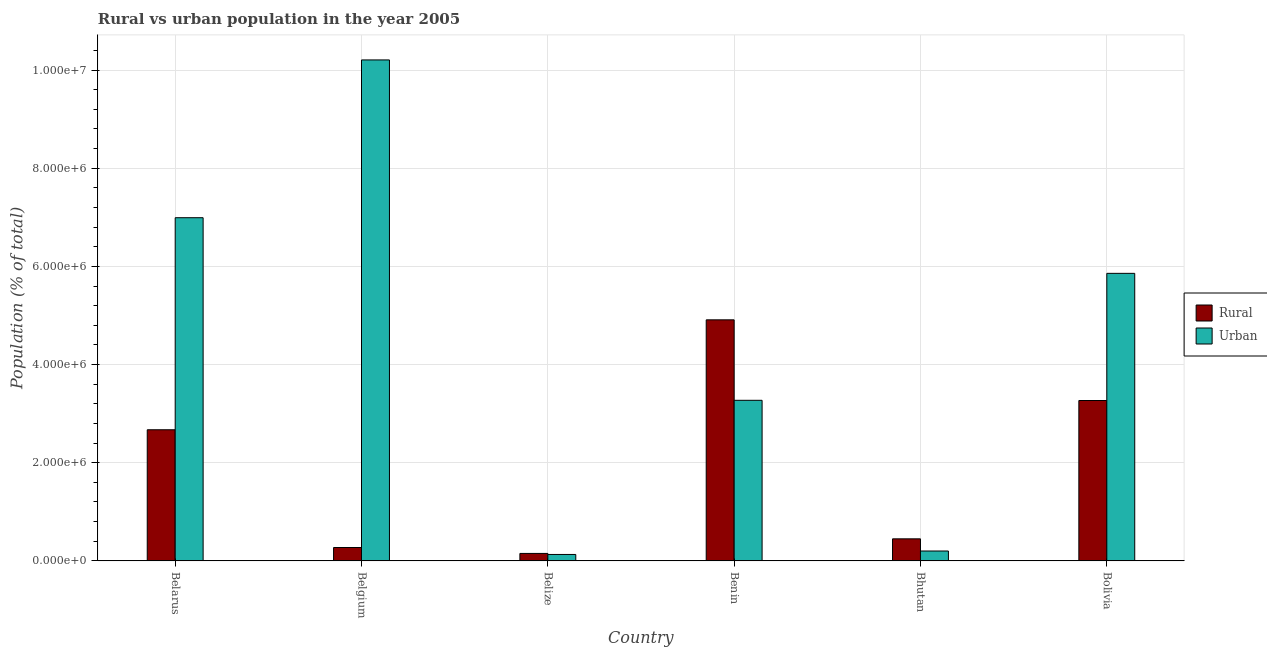How many bars are there on the 6th tick from the left?
Provide a succinct answer. 2. How many bars are there on the 5th tick from the right?
Your answer should be compact. 2. What is the label of the 1st group of bars from the left?
Provide a short and direct response. Belarus. In how many cases, is the number of bars for a given country not equal to the number of legend labels?
Your answer should be compact. 0. What is the rural population density in Belgium?
Keep it short and to the point. 2.73e+05. Across all countries, what is the maximum urban population density?
Your answer should be compact. 1.02e+07. Across all countries, what is the minimum urban population density?
Make the answer very short. 1.31e+05. In which country was the rural population density maximum?
Offer a terse response. Benin. In which country was the rural population density minimum?
Ensure brevity in your answer.  Belize. What is the total urban population density in the graph?
Offer a very short reply. 2.67e+07. What is the difference between the urban population density in Belize and that in Bhutan?
Offer a terse response. -7.04e+04. What is the difference between the rural population density in Benin and the urban population density in Bhutan?
Make the answer very short. 4.71e+06. What is the average urban population density per country?
Offer a very short reply. 4.44e+06. What is the difference between the rural population density and urban population density in Belgium?
Offer a terse response. -9.93e+06. What is the ratio of the urban population density in Belarus to that in Benin?
Make the answer very short. 2.14. What is the difference between the highest and the second highest rural population density?
Make the answer very short. 1.64e+06. What is the difference between the highest and the lowest rural population density?
Your answer should be compact. 4.76e+06. In how many countries, is the urban population density greater than the average urban population density taken over all countries?
Your answer should be very brief. 3. What does the 2nd bar from the left in Bolivia represents?
Provide a succinct answer. Urban. What does the 1st bar from the right in Belgium represents?
Your answer should be compact. Urban. Are all the bars in the graph horizontal?
Ensure brevity in your answer.  No. How many countries are there in the graph?
Provide a succinct answer. 6. What is the difference between two consecutive major ticks on the Y-axis?
Provide a succinct answer. 2.00e+06. Does the graph contain any zero values?
Provide a short and direct response. No. Does the graph contain grids?
Your response must be concise. Yes. How are the legend labels stacked?
Make the answer very short. Vertical. What is the title of the graph?
Make the answer very short. Rural vs urban population in the year 2005. What is the label or title of the Y-axis?
Offer a terse response. Population (% of total). What is the Population (% of total) of Rural in Belarus?
Provide a short and direct response. 2.67e+06. What is the Population (% of total) in Urban in Belarus?
Provide a short and direct response. 6.99e+06. What is the Population (% of total) of Rural in Belgium?
Your response must be concise. 2.73e+05. What is the Population (% of total) in Urban in Belgium?
Offer a terse response. 1.02e+07. What is the Population (% of total) of Rural in Belize?
Offer a terse response. 1.52e+05. What is the Population (% of total) in Urban in Belize?
Provide a short and direct response. 1.31e+05. What is the Population (% of total) of Rural in Benin?
Your answer should be compact. 4.91e+06. What is the Population (% of total) of Urban in Benin?
Ensure brevity in your answer.  3.27e+06. What is the Population (% of total) in Rural in Bhutan?
Your answer should be very brief. 4.50e+05. What is the Population (% of total) of Urban in Bhutan?
Provide a succinct answer. 2.02e+05. What is the Population (% of total) of Rural in Bolivia?
Ensure brevity in your answer.  3.27e+06. What is the Population (% of total) of Urban in Bolivia?
Make the answer very short. 5.86e+06. Across all countries, what is the maximum Population (% of total) of Rural?
Provide a short and direct response. 4.91e+06. Across all countries, what is the maximum Population (% of total) of Urban?
Give a very brief answer. 1.02e+07. Across all countries, what is the minimum Population (% of total) of Rural?
Ensure brevity in your answer.  1.52e+05. Across all countries, what is the minimum Population (% of total) of Urban?
Give a very brief answer. 1.31e+05. What is the total Population (% of total) in Rural in the graph?
Make the answer very short. 1.17e+07. What is the total Population (% of total) of Urban in the graph?
Offer a terse response. 2.67e+07. What is the difference between the Population (% of total) in Rural in Belarus and that in Belgium?
Offer a terse response. 2.40e+06. What is the difference between the Population (% of total) of Urban in Belarus and that in Belgium?
Ensure brevity in your answer.  -3.21e+06. What is the difference between the Population (% of total) of Rural in Belarus and that in Belize?
Your answer should be very brief. 2.52e+06. What is the difference between the Population (% of total) of Urban in Belarus and that in Belize?
Your response must be concise. 6.86e+06. What is the difference between the Population (% of total) in Rural in Belarus and that in Benin?
Your answer should be very brief. -2.24e+06. What is the difference between the Population (% of total) of Urban in Belarus and that in Benin?
Provide a succinct answer. 3.72e+06. What is the difference between the Population (% of total) in Rural in Belarus and that in Bhutan?
Keep it short and to the point. 2.22e+06. What is the difference between the Population (% of total) of Urban in Belarus and that in Bhutan?
Your answer should be compact. 6.79e+06. What is the difference between the Population (% of total) in Rural in Belarus and that in Bolivia?
Provide a short and direct response. -5.96e+05. What is the difference between the Population (% of total) of Urban in Belarus and that in Bolivia?
Keep it short and to the point. 1.13e+06. What is the difference between the Population (% of total) in Rural in Belgium and that in Belize?
Provide a short and direct response. 1.21e+05. What is the difference between the Population (% of total) of Urban in Belgium and that in Belize?
Ensure brevity in your answer.  1.01e+07. What is the difference between the Population (% of total) of Rural in Belgium and that in Benin?
Provide a succinct answer. -4.64e+06. What is the difference between the Population (% of total) of Urban in Belgium and that in Benin?
Keep it short and to the point. 6.93e+06. What is the difference between the Population (% of total) in Rural in Belgium and that in Bhutan?
Keep it short and to the point. -1.77e+05. What is the difference between the Population (% of total) of Urban in Belgium and that in Bhutan?
Your answer should be compact. 1.00e+07. What is the difference between the Population (% of total) of Rural in Belgium and that in Bolivia?
Provide a short and direct response. -2.99e+06. What is the difference between the Population (% of total) of Urban in Belgium and that in Bolivia?
Make the answer very short. 4.35e+06. What is the difference between the Population (% of total) in Rural in Belize and that in Benin?
Offer a terse response. -4.76e+06. What is the difference between the Population (% of total) in Urban in Belize and that in Benin?
Offer a terse response. -3.14e+06. What is the difference between the Population (% of total) of Rural in Belize and that in Bhutan?
Offer a terse response. -2.97e+05. What is the difference between the Population (% of total) in Urban in Belize and that in Bhutan?
Offer a terse response. -7.04e+04. What is the difference between the Population (% of total) in Rural in Belize and that in Bolivia?
Your response must be concise. -3.12e+06. What is the difference between the Population (% of total) of Urban in Belize and that in Bolivia?
Offer a terse response. -5.73e+06. What is the difference between the Population (% of total) in Rural in Benin and that in Bhutan?
Provide a succinct answer. 4.46e+06. What is the difference between the Population (% of total) in Urban in Benin and that in Bhutan?
Your answer should be very brief. 3.07e+06. What is the difference between the Population (% of total) in Rural in Benin and that in Bolivia?
Ensure brevity in your answer.  1.64e+06. What is the difference between the Population (% of total) in Urban in Benin and that in Bolivia?
Your response must be concise. -2.59e+06. What is the difference between the Population (% of total) in Rural in Bhutan and that in Bolivia?
Your answer should be very brief. -2.82e+06. What is the difference between the Population (% of total) in Urban in Bhutan and that in Bolivia?
Provide a short and direct response. -5.66e+06. What is the difference between the Population (% of total) of Rural in Belarus and the Population (% of total) of Urban in Belgium?
Make the answer very short. -7.53e+06. What is the difference between the Population (% of total) of Rural in Belarus and the Population (% of total) of Urban in Belize?
Give a very brief answer. 2.54e+06. What is the difference between the Population (% of total) in Rural in Belarus and the Population (% of total) in Urban in Benin?
Offer a terse response. -6.00e+05. What is the difference between the Population (% of total) of Rural in Belarus and the Population (% of total) of Urban in Bhutan?
Offer a terse response. 2.47e+06. What is the difference between the Population (% of total) of Rural in Belarus and the Population (% of total) of Urban in Bolivia?
Offer a very short reply. -3.19e+06. What is the difference between the Population (% of total) of Rural in Belgium and the Population (% of total) of Urban in Belize?
Provide a succinct answer. 1.42e+05. What is the difference between the Population (% of total) of Rural in Belgium and the Population (% of total) of Urban in Benin?
Your answer should be compact. -3.00e+06. What is the difference between the Population (% of total) of Rural in Belgium and the Population (% of total) of Urban in Bhutan?
Provide a short and direct response. 7.11e+04. What is the difference between the Population (% of total) in Rural in Belgium and the Population (% of total) in Urban in Bolivia?
Make the answer very short. -5.59e+06. What is the difference between the Population (% of total) in Rural in Belize and the Population (% of total) in Urban in Benin?
Offer a terse response. -3.12e+06. What is the difference between the Population (% of total) in Rural in Belize and the Population (% of total) in Urban in Bhutan?
Give a very brief answer. -4.95e+04. What is the difference between the Population (% of total) of Rural in Belize and the Population (% of total) of Urban in Bolivia?
Make the answer very short. -5.71e+06. What is the difference between the Population (% of total) of Rural in Benin and the Population (% of total) of Urban in Bhutan?
Your answer should be very brief. 4.71e+06. What is the difference between the Population (% of total) of Rural in Benin and the Population (% of total) of Urban in Bolivia?
Give a very brief answer. -9.47e+05. What is the difference between the Population (% of total) of Rural in Bhutan and the Population (% of total) of Urban in Bolivia?
Offer a very short reply. -5.41e+06. What is the average Population (% of total) of Rural per country?
Give a very brief answer. 1.95e+06. What is the average Population (% of total) in Urban per country?
Make the answer very short. 4.44e+06. What is the difference between the Population (% of total) of Rural and Population (% of total) of Urban in Belarus?
Keep it short and to the point. -4.32e+06. What is the difference between the Population (% of total) of Rural and Population (% of total) of Urban in Belgium?
Your answer should be very brief. -9.93e+06. What is the difference between the Population (% of total) of Rural and Population (% of total) of Urban in Belize?
Your answer should be very brief. 2.09e+04. What is the difference between the Population (% of total) in Rural and Population (% of total) in Urban in Benin?
Offer a very short reply. 1.64e+06. What is the difference between the Population (% of total) of Rural and Population (% of total) of Urban in Bhutan?
Provide a succinct answer. 2.48e+05. What is the difference between the Population (% of total) of Rural and Population (% of total) of Urban in Bolivia?
Offer a terse response. -2.59e+06. What is the ratio of the Population (% of total) in Rural in Belarus to that in Belgium?
Make the answer very short. 9.79. What is the ratio of the Population (% of total) of Urban in Belarus to that in Belgium?
Provide a short and direct response. 0.69. What is the ratio of the Population (% of total) of Rural in Belarus to that in Belize?
Offer a very short reply. 17.56. What is the ratio of the Population (% of total) of Urban in Belarus to that in Belize?
Give a very brief answer. 53.29. What is the ratio of the Population (% of total) of Rural in Belarus to that in Benin?
Keep it short and to the point. 0.54. What is the ratio of the Population (% of total) in Urban in Belarus to that in Benin?
Your answer should be compact. 2.14. What is the ratio of the Population (% of total) of Rural in Belarus to that in Bhutan?
Your response must be concise. 5.94. What is the ratio of the Population (% of total) of Urban in Belarus to that in Bhutan?
Offer a terse response. 34.67. What is the ratio of the Population (% of total) of Rural in Belarus to that in Bolivia?
Keep it short and to the point. 0.82. What is the ratio of the Population (% of total) of Urban in Belarus to that in Bolivia?
Provide a succinct answer. 1.19. What is the ratio of the Population (% of total) in Rural in Belgium to that in Belize?
Provide a short and direct response. 1.79. What is the ratio of the Population (% of total) in Urban in Belgium to that in Belize?
Offer a terse response. 77.8. What is the ratio of the Population (% of total) in Rural in Belgium to that in Benin?
Provide a succinct answer. 0.06. What is the ratio of the Population (% of total) of Urban in Belgium to that in Benin?
Offer a very short reply. 3.12. What is the ratio of the Population (% of total) of Rural in Belgium to that in Bhutan?
Your response must be concise. 0.61. What is the ratio of the Population (% of total) in Urban in Belgium to that in Bhutan?
Your response must be concise. 50.62. What is the ratio of the Population (% of total) of Rural in Belgium to that in Bolivia?
Ensure brevity in your answer.  0.08. What is the ratio of the Population (% of total) of Urban in Belgium to that in Bolivia?
Your answer should be compact. 1.74. What is the ratio of the Population (% of total) in Rural in Belize to that in Benin?
Give a very brief answer. 0.03. What is the ratio of the Population (% of total) of Urban in Belize to that in Benin?
Make the answer very short. 0.04. What is the ratio of the Population (% of total) in Rural in Belize to that in Bhutan?
Your answer should be compact. 0.34. What is the ratio of the Population (% of total) of Urban in Belize to that in Bhutan?
Offer a terse response. 0.65. What is the ratio of the Population (% of total) of Rural in Belize to that in Bolivia?
Offer a very short reply. 0.05. What is the ratio of the Population (% of total) in Urban in Belize to that in Bolivia?
Offer a very short reply. 0.02. What is the ratio of the Population (% of total) in Rural in Benin to that in Bhutan?
Your response must be concise. 10.92. What is the ratio of the Population (% of total) of Urban in Benin to that in Bhutan?
Offer a terse response. 16.22. What is the ratio of the Population (% of total) in Rural in Benin to that in Bolivia?
Ensure brevity in your answer.  1.5. What is the ratio of the Population (% of total) of Urban in Benin to that in Bolivia?
Ensure brevity in your answer.  0.56. What is the ratio of the Population (% of total) in Rural in Bhutan to that in Bolivia?
Make the answer very short. 0.14. What is the ratio of the Population (% of total) in Urban in Bhutan to that in Bolivia?
Your answer should be compact. 0.03. What is the difference between the highest and the second highest Population (% of total) of Rural?
Your response must be concise. 1.64e+06. What is the difference between the highest and the second highest Population (% of total) in Urban?
Your answer should be compact. 3.21e+06. What is the difference between the highest and the lowest Population (% of total) in Rural?
Offer a terse response. 4.76e+06. What is the difference between the highest and the lowest Population (% of total) of Urban?
Offer a terse response. 1.01e+07. 